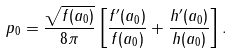<formula> <loc_0><loc_0><loc_500><loc_500>p _ { 0 } = \frac { \sqrt { f ( a _ { 0 } ) } } { 8 \pi } \left [ \frac { f ^ { \prime } ( a _ { 0 } ) } { f ( a _ { 0 } ) } + \frac { h ^ { \prime } ( a _ { 0 } ) } { h ( a _ { 0 } ) } \right ] .</formula> 